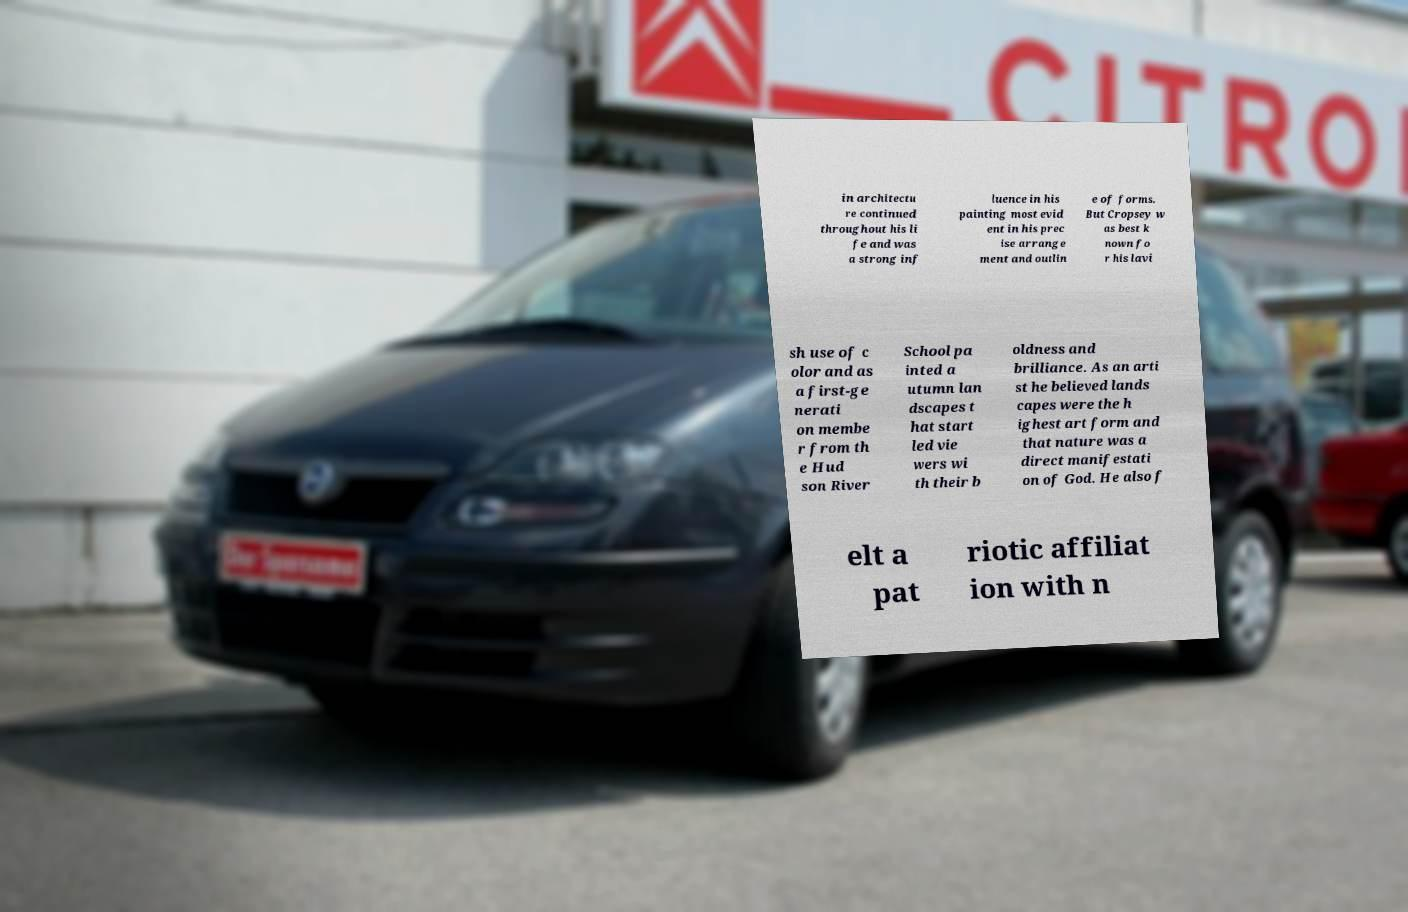There's text embedded in this image that I need extracted. Can you transcribe it verbatim? in architectu re continued throughout his li fe and was a strong inf luence in his painting most evid ent in his prec ise arrange ment and outlin e of forms. But Cropsey w as best k nown fo r his lavi sh use of c olor and as a first-ge nerati on membe r from th e Hud son River School pa inted a utumn lan dscapes t hat start led vie wers wi th their b oldness and brilliance. As an arti st he believed lands capes were the h ighest art form and that nature was a direct manifestati on of God. He also f elt a pat riotic affiliat ion with n 